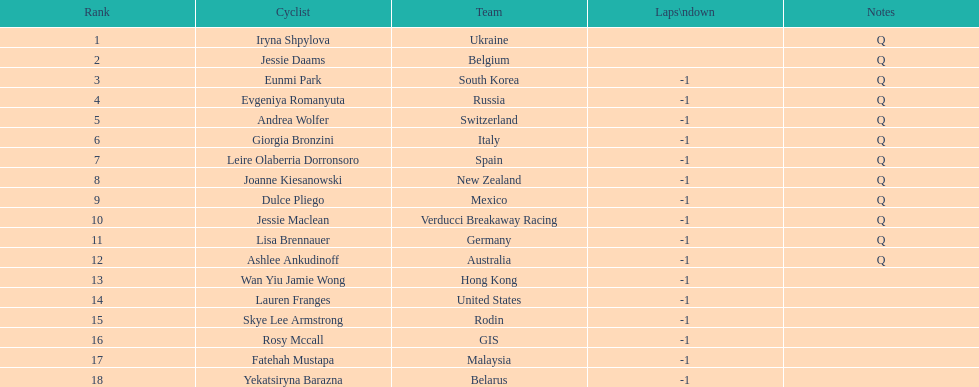Who was the rival that completed ahead of jessie maclean? Dulce Pliego. 